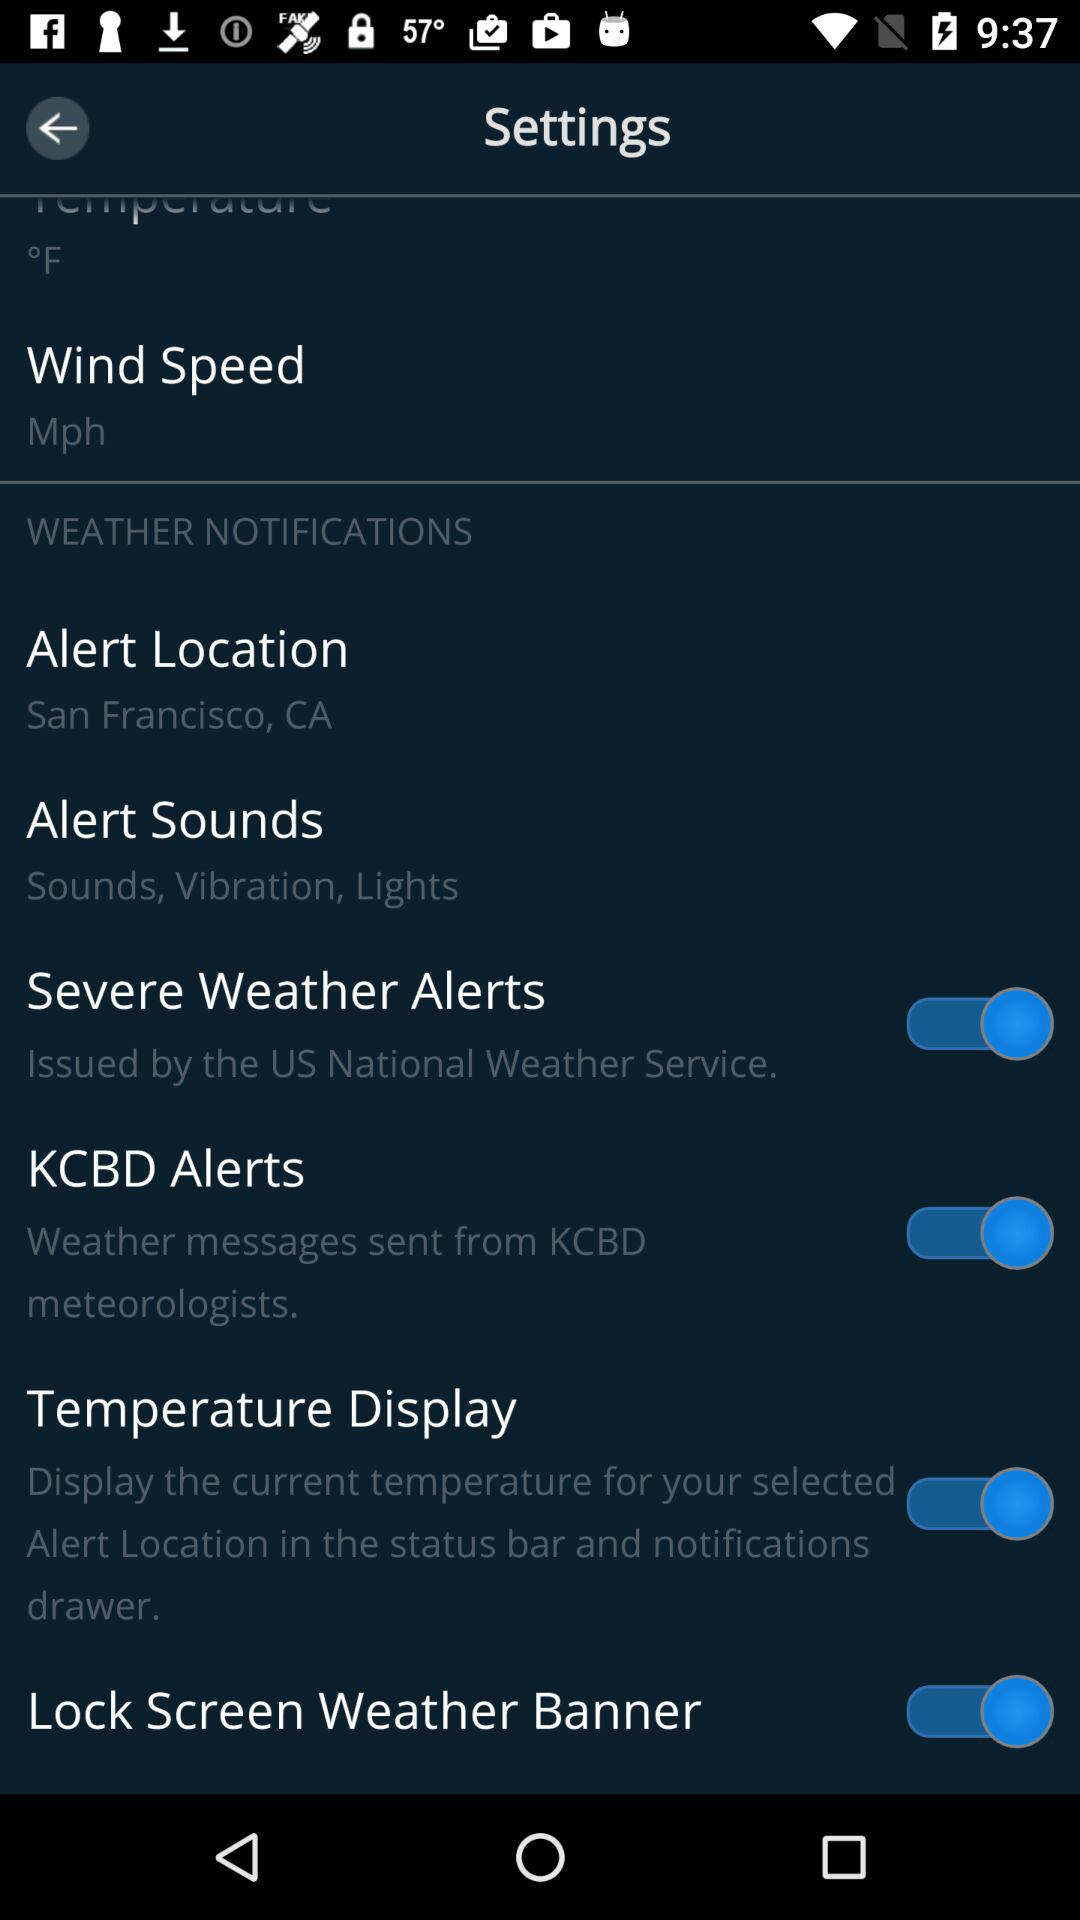What location is the "Alert Location" set for? It is set for San Francisco, CA. 